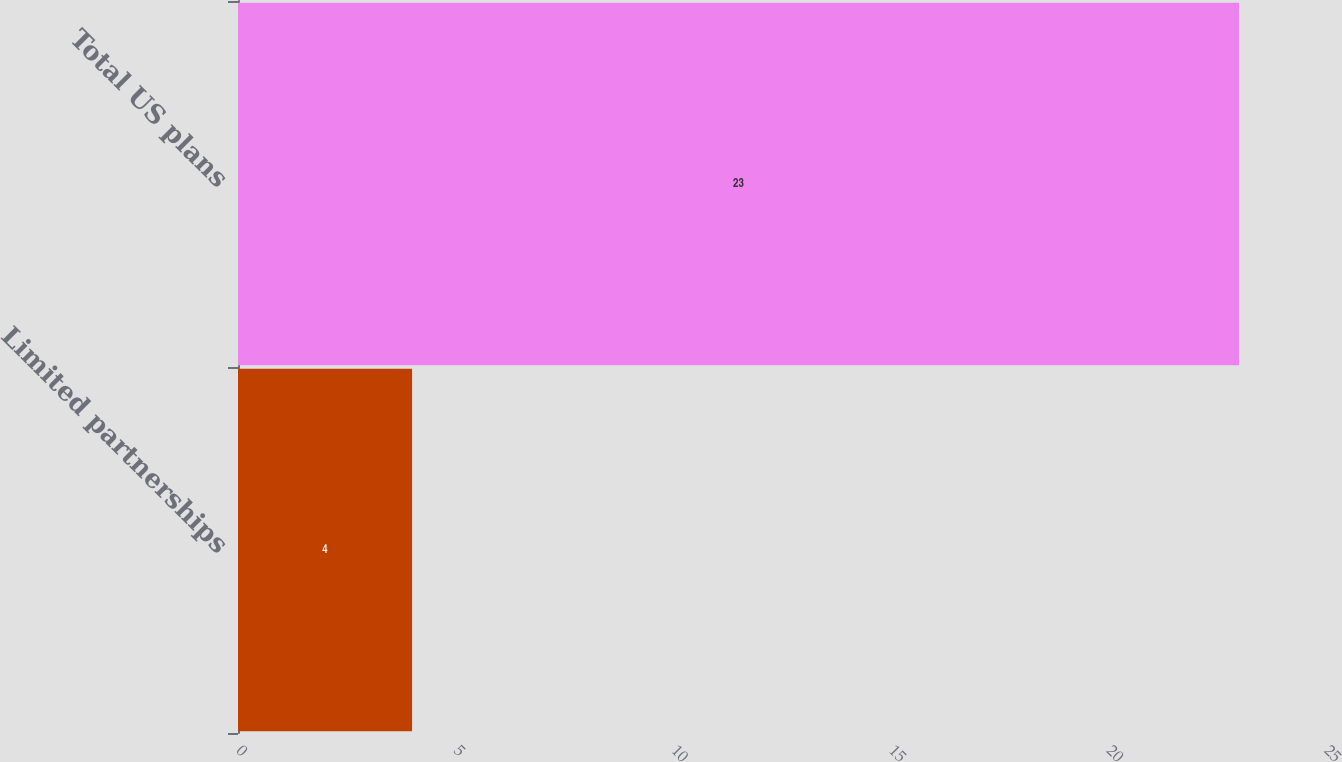<chart> <loc_0><loc_0><loc_500><loc_500><bar_chart><fcel>Limited partnerships<fcel>Total US plans<nl><fcel>4<fcel>23<nl></chart> 